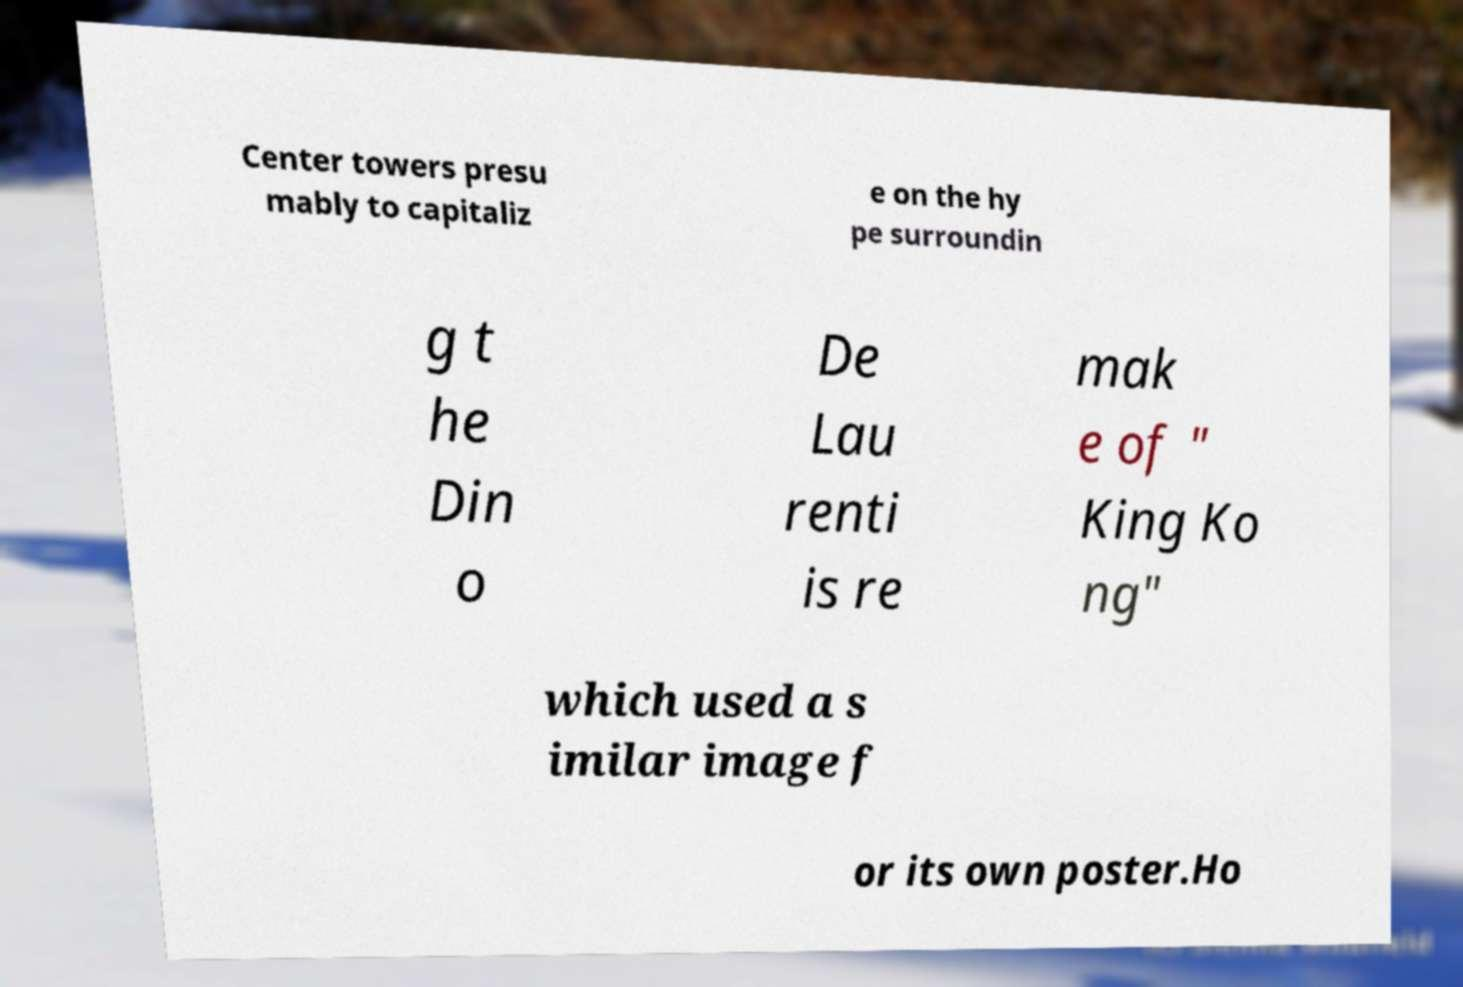Can you read and provide the text displayed in the image?This photo seems to have some interesting text. Can you extract and type it out for me? Center towers presu mably to capitaliz e on the hy pe surroundin g t he Din o De Lau renti is re mak e of " King Ko ng" which used a s imilar image f or its own poster.Ho 